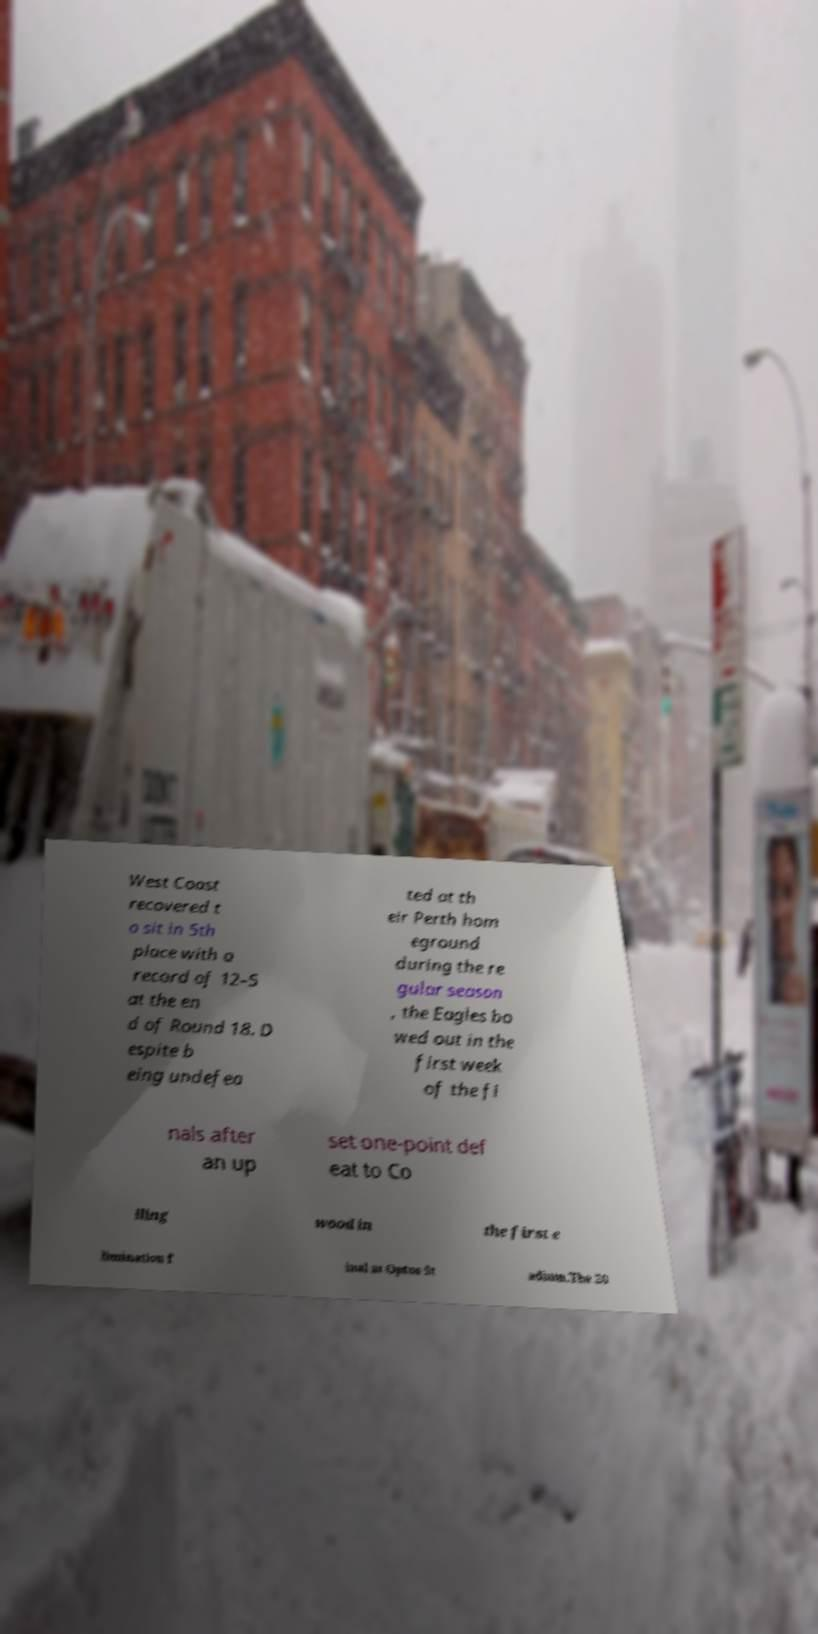For documentation purposes, I need the text within this image transcribed. Could you provide that? West Coast recovered t o sit in 5th place with a record of 12–5 at the en d of Round 18. D espite b eing undefea ted at th eir Perth hom eground during the re gular season , the Eagles bo wed out in the first week of the fi nals after an up set one-point def eat to Co lling wood in the first e limination f inal at Optus St adium.The 20 